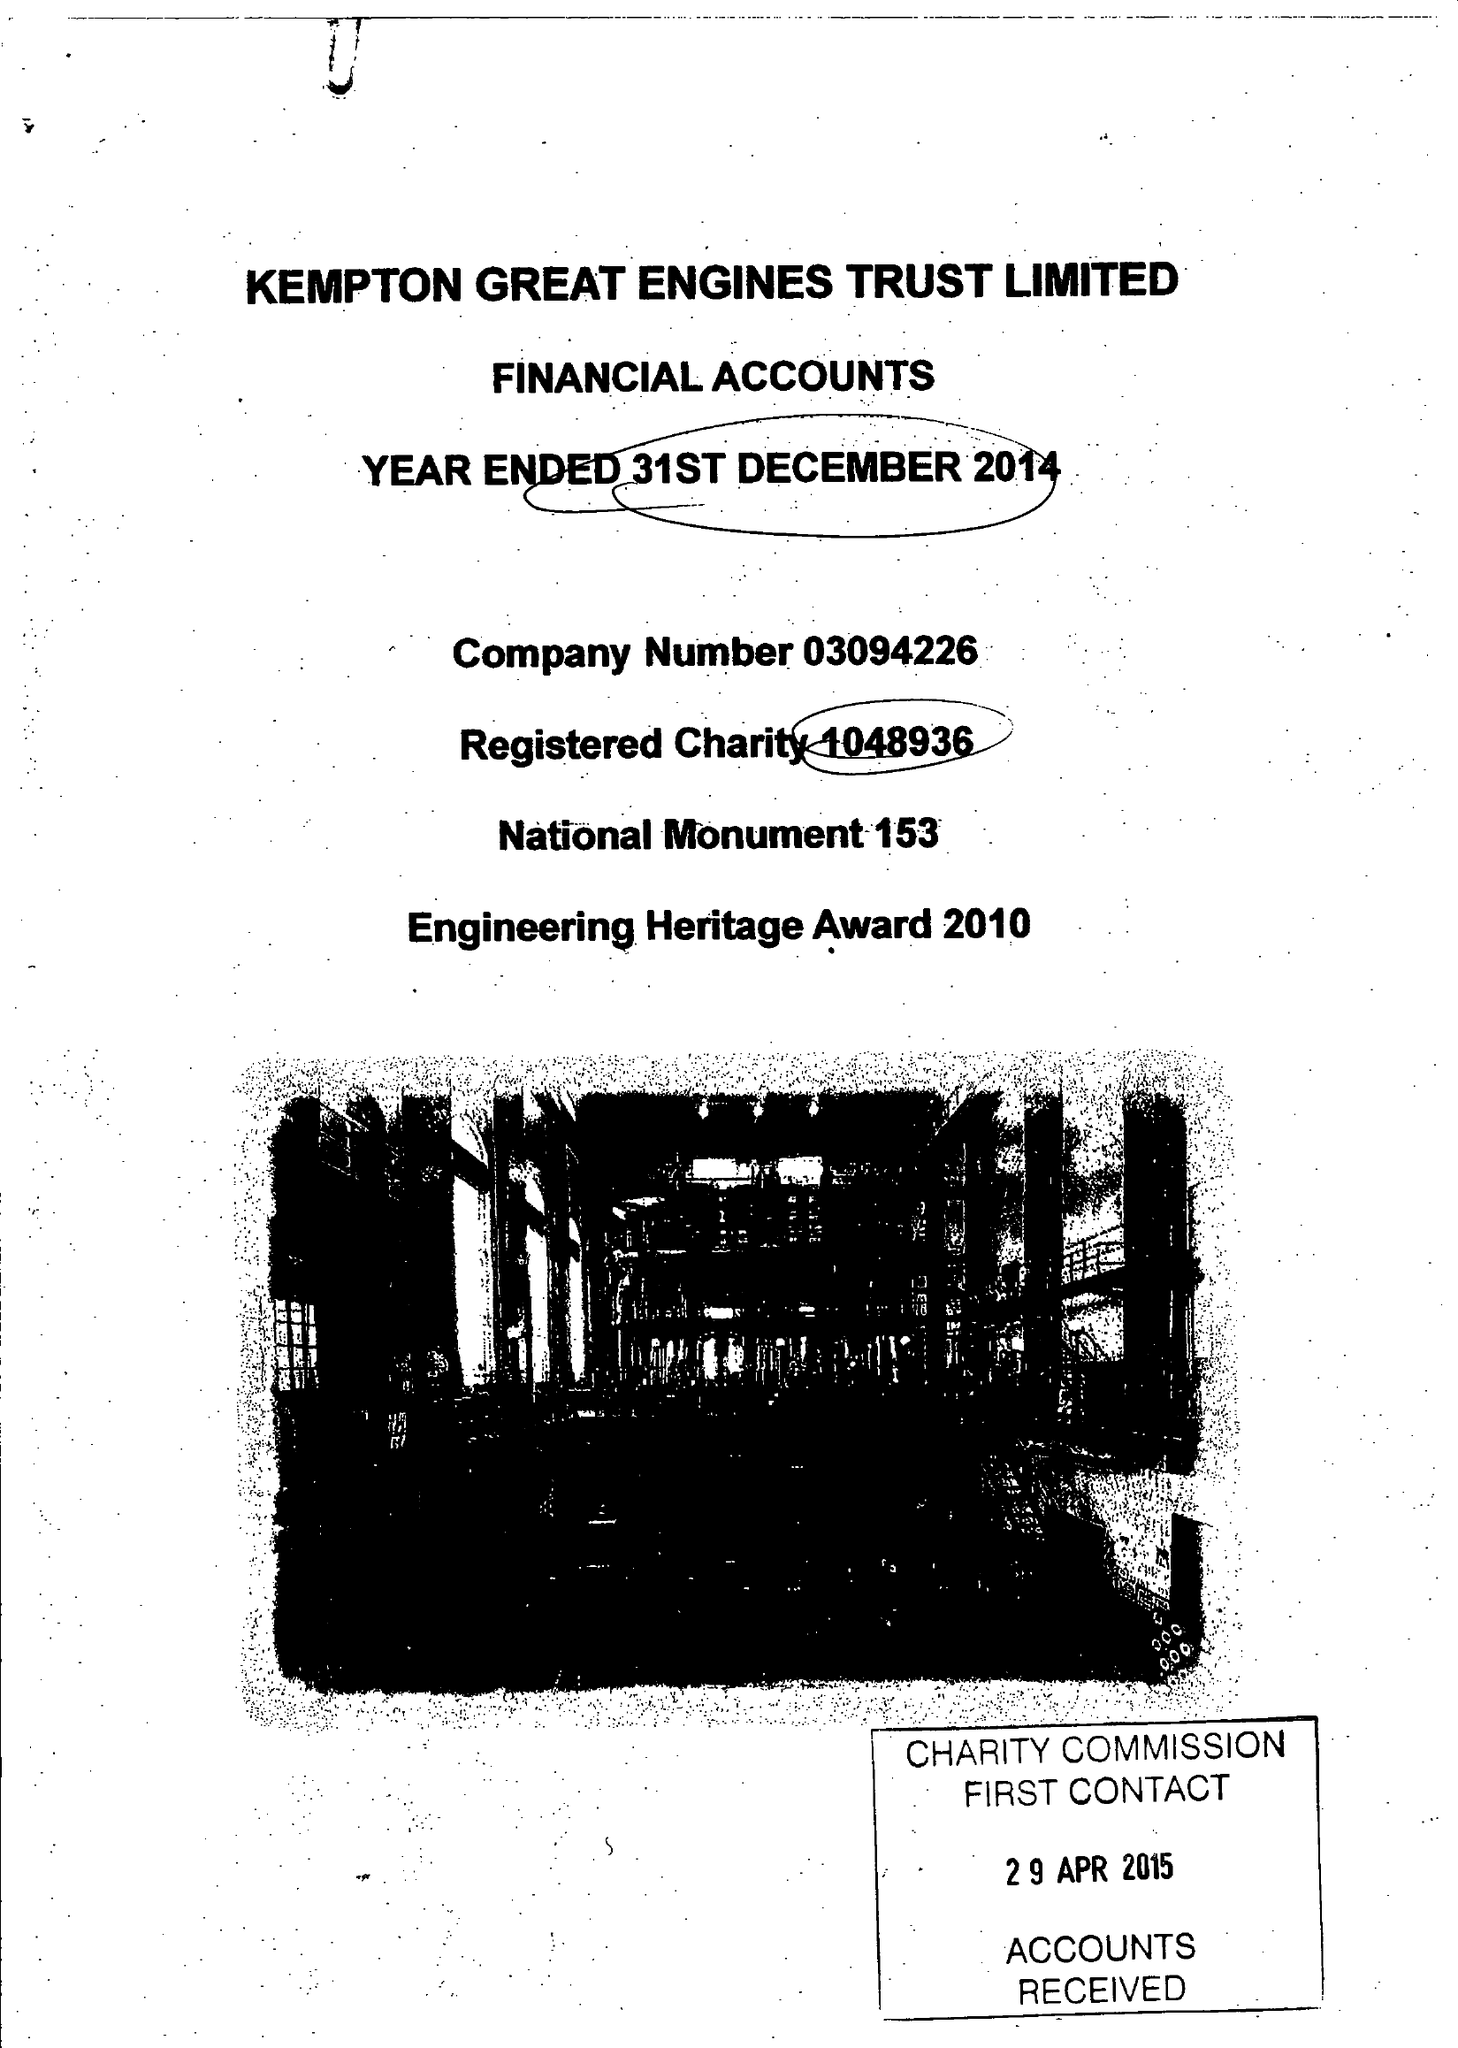What is the value for the address__post_town?
Answer the question using a single word or phrase. FELTHAM 